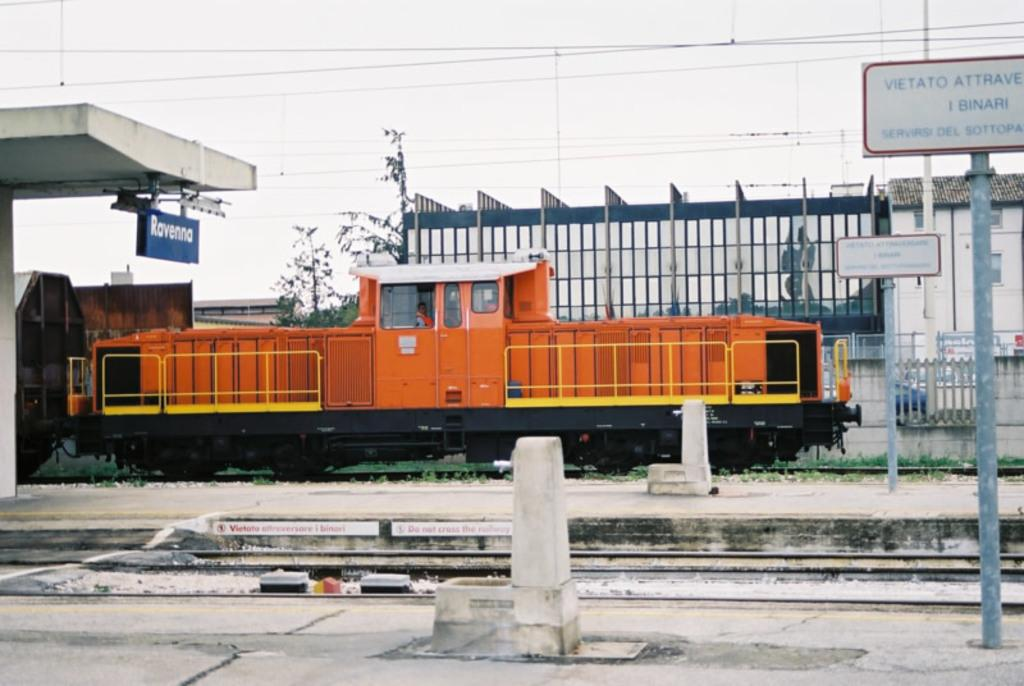<image>
Relay a brief, clear account of the picture shown. red and yellow train parked under a sign which says Ravenna. 